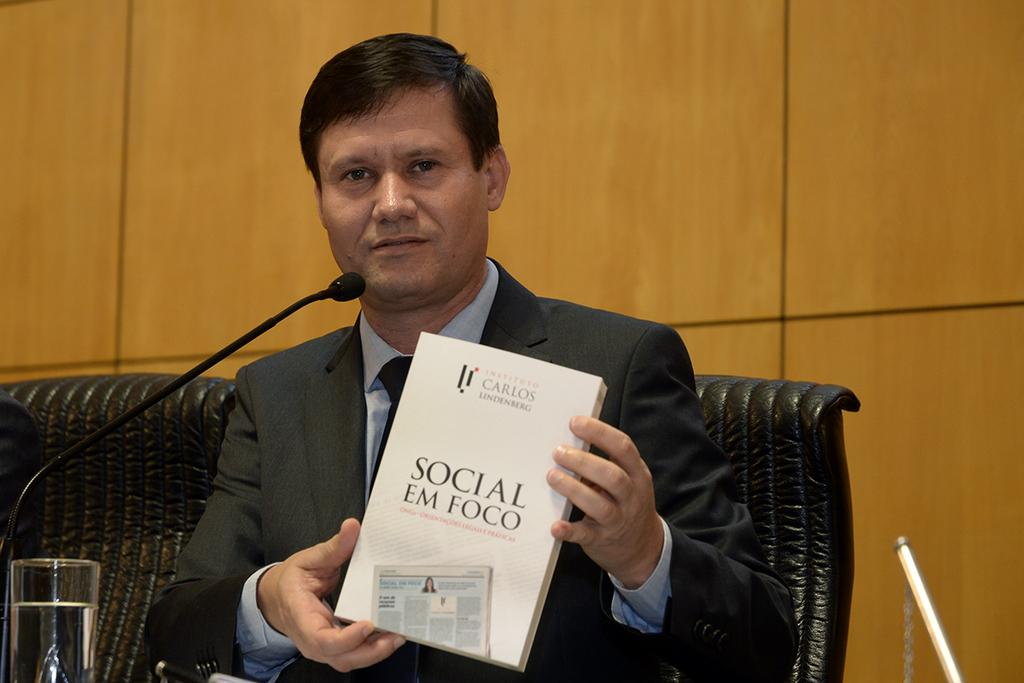<image>
Relay a brief, clear account of the picture shown. A seated man holds a copy of Social Em Foco in his hands. 